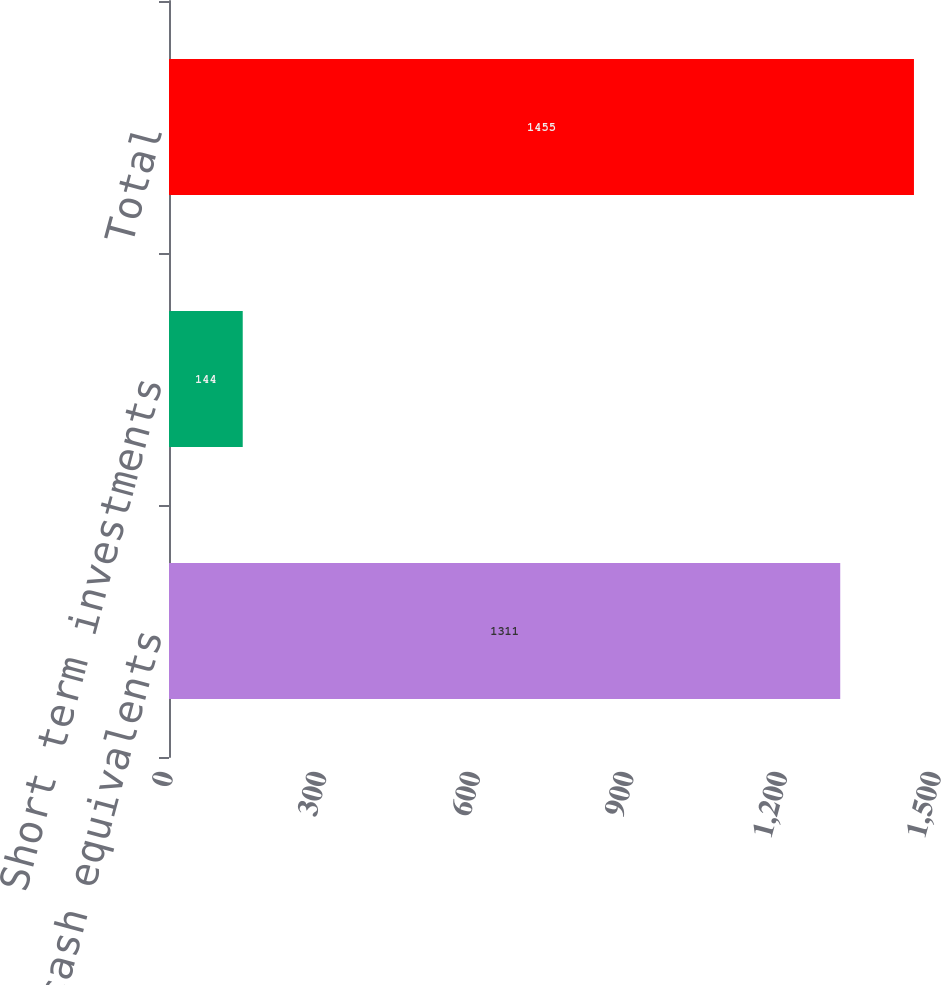Convert chart to OTSL. <chart><loc_0><loc_0><loc_500><loc_500><bar_chart><fcel>Cash and cash equivalents<fcel>Short term investments<fcel>Total<nl><fcel>1311<fcel>144<fcel>1455<nl></chart> 